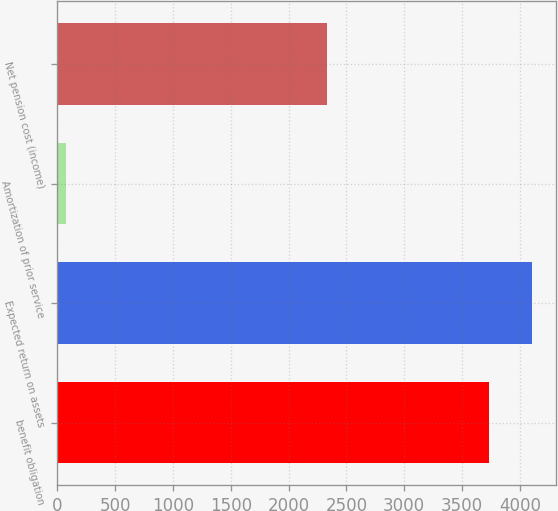Convert chart to OTSL. <chart><loc_0><loc_0><loc_500><loc_500><bar_chart><fcel>benefit obligation<fcel>Expected return on assets<fcel>Amortization of prior service<fcel>Net pension cost (income)<nl><fcel>3735<fcel>4105.3<fcel>72<fcel>2329<nl></chart> 